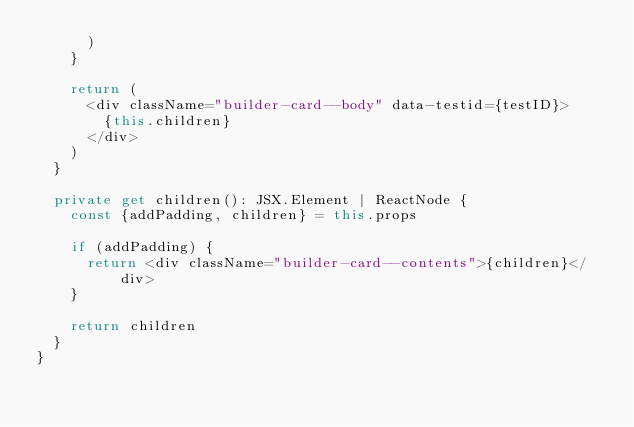Convert code to text. <code><loc_0><loc_0><loc_500><loc_500><_TypeScript_>      )
    }

    return (
      <div className="builder-card--body" data-testid={testID}>
        {this.children}
      </div>
    )
  }

  private get children(): JSX.Element | ReactNode {
    const {addPadding, children} = this.props

    if (addPadding) {
      return <div className="builder-card--contents">{children}</div>
    }

    return children
  }
}
</code> 